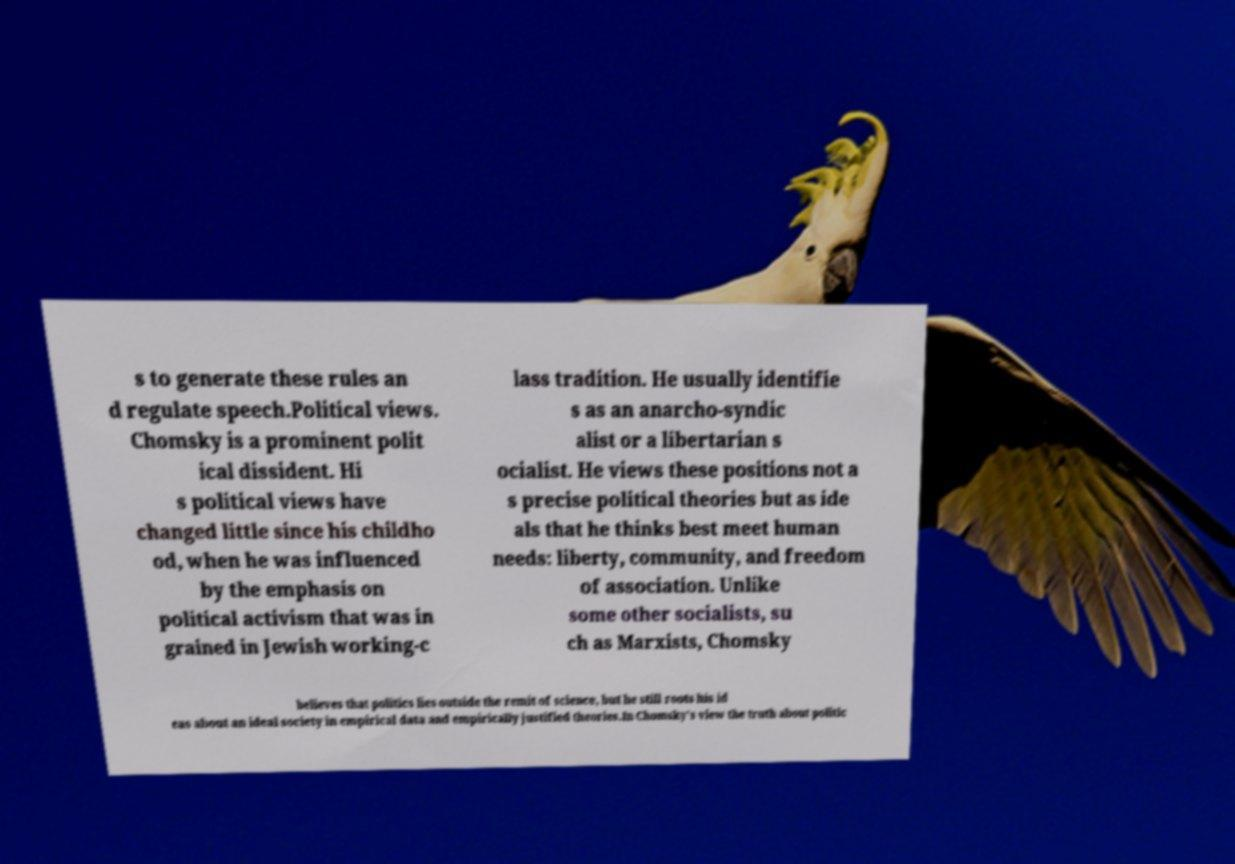Could you assist in decoding the text presented in this image and type it out clearly? s to generate these rules an d regulate speech.Political views. Chomsky is a prominent polit ical dissident. Hi s political views have changed little since his childho od, when he was influenced by the emphasis on political activism that was in grained in Jewish working-c lass tradition. He usually identifie s as an anarcho-syndic alist or a libertarian s ocialist. He views these positions not a s precise political theories but as ide als that he thinks best meet human needs: liberty, community, and freedom of association. Unlike some other socialists, su ch as Marxists, Chomsky believes that politics lies outside the remit of science, but he still roots his id eas about an ideal society in empirical data and empirically justified theories.In Chomsky's view the truth about politic 